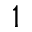Convert formula to latex. <formula><loc_0><loc_0><loc_500><loc_500>1</formula> 